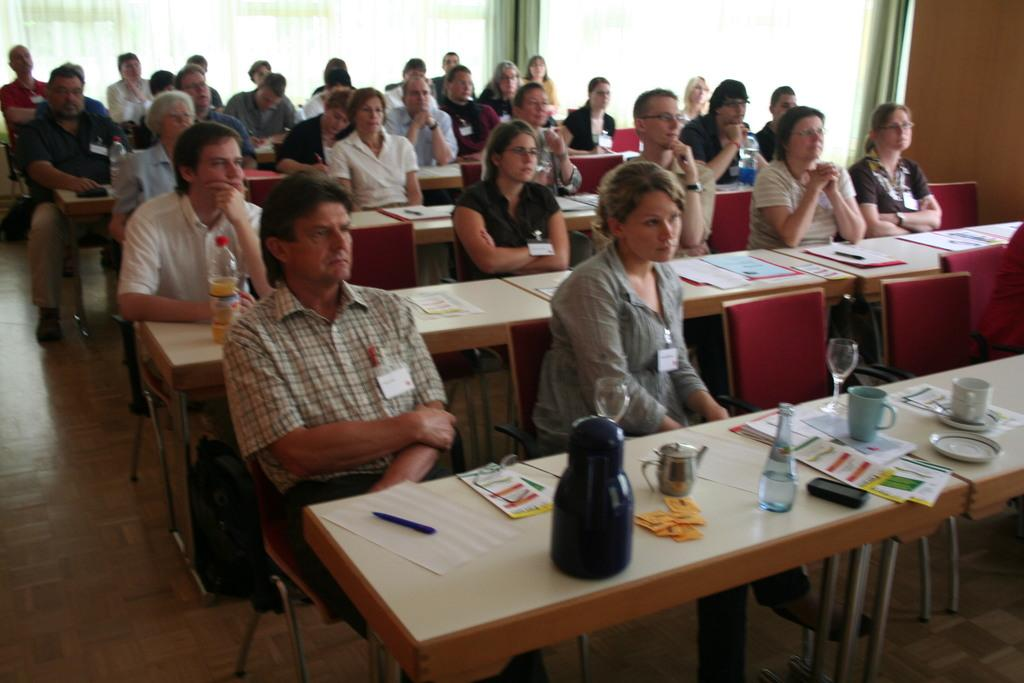What are the people in the image doing? The people in the image are sitting on chairs. What objects are in front of the chairs? There are tables in front of the chairs. What can be seen on one of the tables? There is a mug, a bottle, a cup, and a newspaper on one of the tables. What type of flame can be seen on the governor's nerve in the image? There is no flame, governor, or nerve present in the image. 